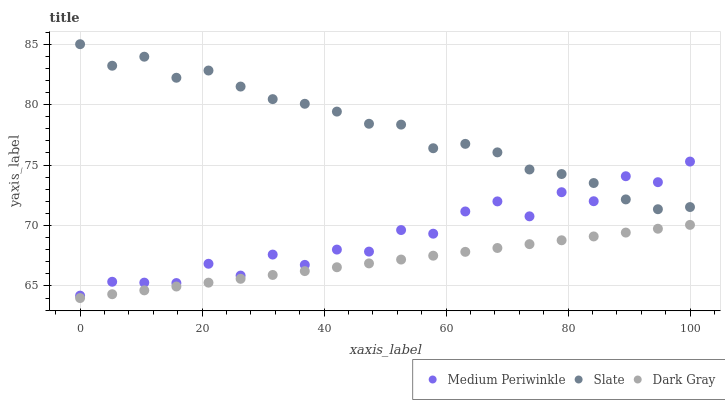Does Dark Gray have the minimum area under the curve?
Answer yes or no. Yes. Does Slate have the maximum area under the curve?
Answer yes or no. Yes. Does Medium Periwinkle have the minimum area under the curve?
Answer yes or no. No. Does Medium Periwinkle have the maximum area under the curve?
Answer yes or no. No. Is Dark Gray the smoothest?
Answer yes or no. Yes. Is Medium Periwinkle the roughest?
Answer yes or no. Yes. Is Slate the smoothest?
Answer yes or no. No. Is Slate the roughest?
Answer yes or no. No. Does Dark Gray have the lowest value?
Answer yes or no. Yes. Does Medium Periwinkle have the lowest value?
Answer yes or no. No. Does Slate have the highest value?
Answer yes or no. Yes. Does Medium Periwinkle have the highest value?
Answer yes or no. No. Is Dark Gray less than Medium Periwinkle?
Answer yes or no. Yes. Is Medium Periwinkle greater than Dark Gray?
Answer yes or no. Yes. Does Medium Periwinkle intersect Slate?
Answer yes or no. Yes. Is Medium Periwinkle less than Slate?
Answer yes or no. No. Is Medium Periwinkle greater than Slate?
Answer yes or no. No. Does Dark Gray intersect Medium Periwinkle?
Answer yes or no. No. 